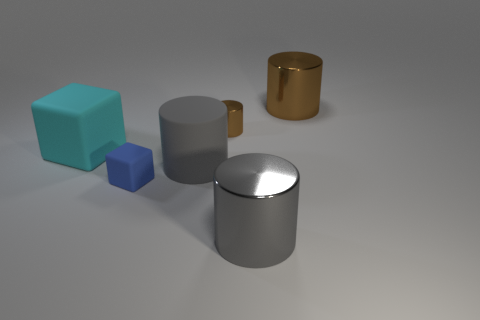Subtract all large matte cylinders. How many cylinders are left? 3 Subtract all brown cylinders. How many cylinders are left? 2 Add 2 large gray rubber cylinders. How many objects exist? 8 Subtract 1 cubes. How many cubes are left? 1 Subtract all yellow cylinders. Subtract all brown blocks. How many cylinders are left? 4 Subtract all purple cylinders. How many blue cubes are left? 1 Subtract all big brown metallic things. Subtract all big cyan cubes. How many objects are left? 4 Add 2 shiny things. How many shiny things are left? 5 Add 6 brown things. How many brown things exist? 8 Subtract 0 brown balls. How many objects are left? 6 